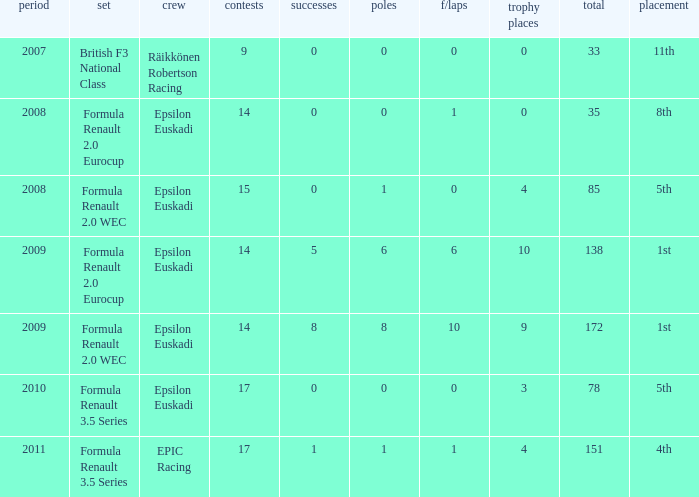How many f/laps when he finished 8th? 1.0. 